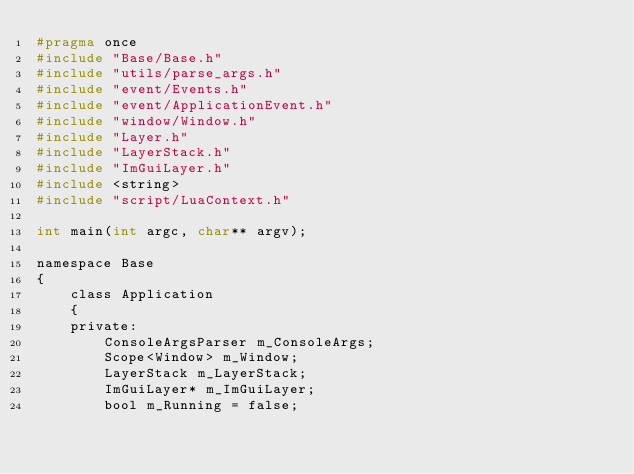<code> <loc_0><loc_0><loc_500><loc_500><_C_>#pragma once
#include "Base/Base.h"
#include "utils/parse_args.h"
#include "event/Events.h"
#include "event/ApplicationEvent.h"
#include "window/Window.h"
#include "Layer.h"
#include "LayerStack.h"
#include "ImGuiLayer.h"
#include <string>
#include "script/LuaContext.h"

int main(int argc, char** argv);

namespace Base
{
	class Application
	{
	private:
		ConsoleArgsParser m_ConsoleArgs;
		Scope<Window> m_Window;
		LayerStack m_LayerStack;
		ImGuiLayer* m_ImGuiLayer;
		bool m_Running = false;</code> 